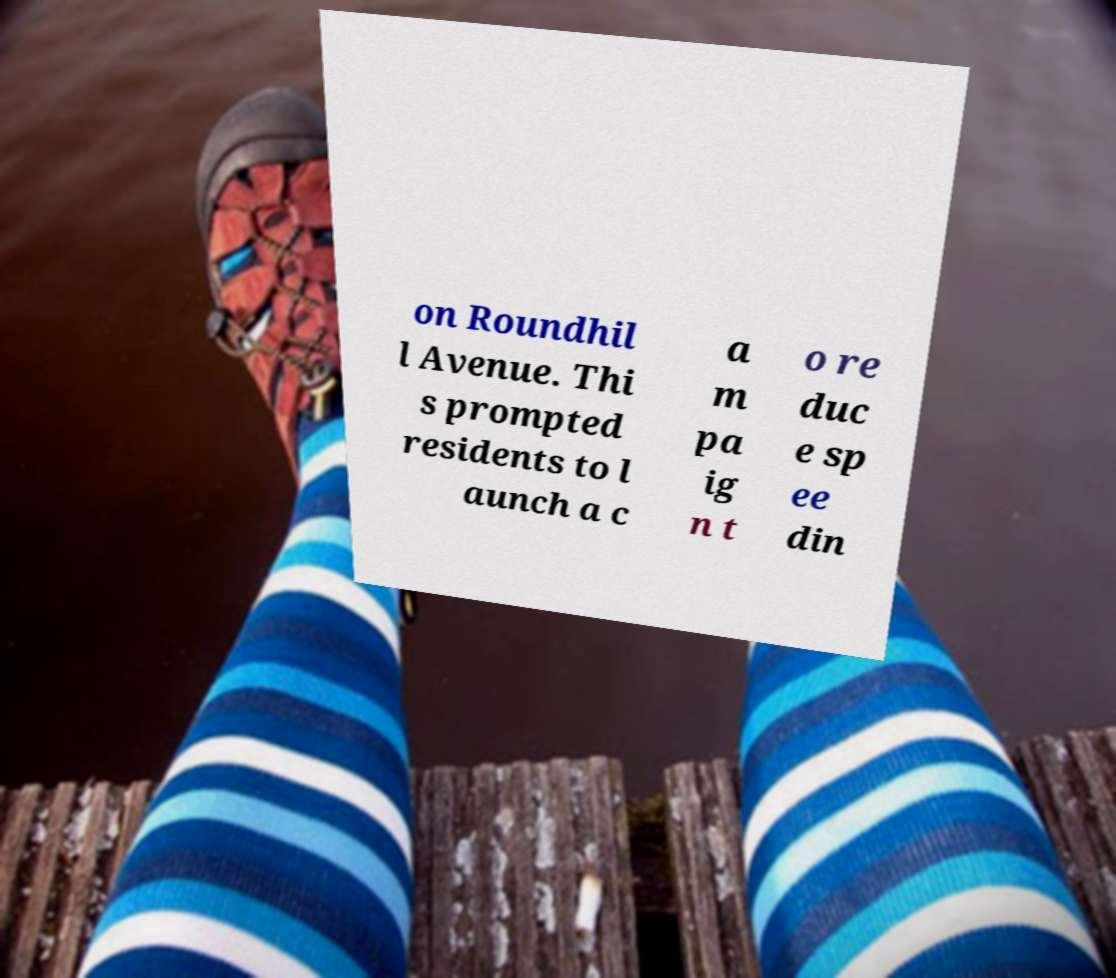Can you read and provide the text displayed in the image?This photo seems to have some interesting text. Can you extract and type it out for me? on Roundhil l Avenue. Thi s prompted residents to l aunch a c a m pa ig n t o re duc e sp ee din 